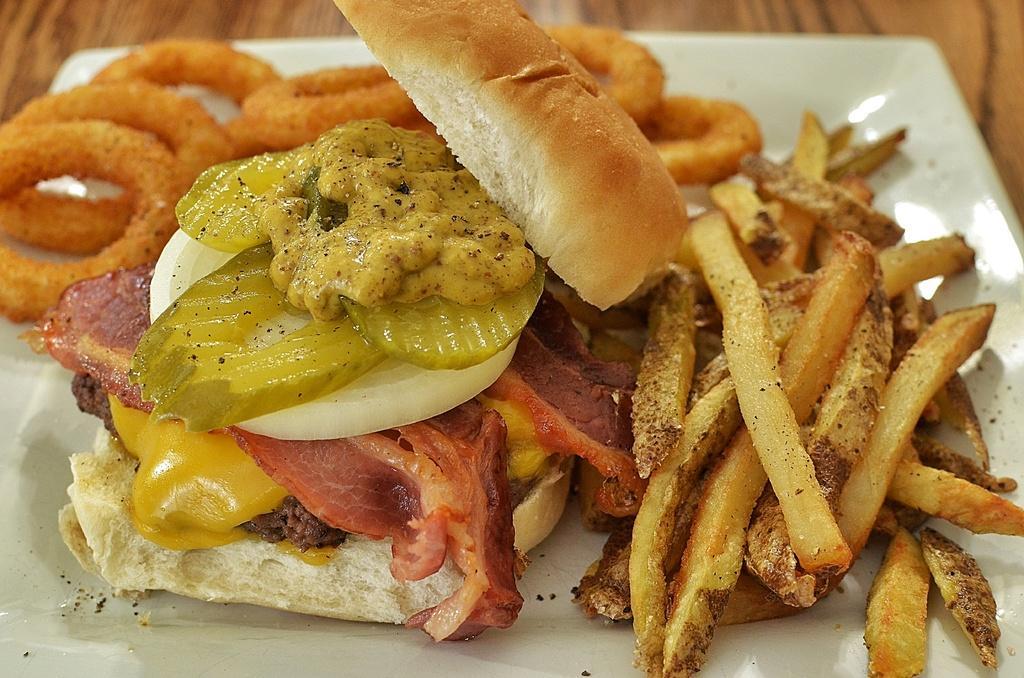Could you give a brief overview of what you see in this image? In this picture there is a tray in the center of the image, which contains french fries and a burger in it. 